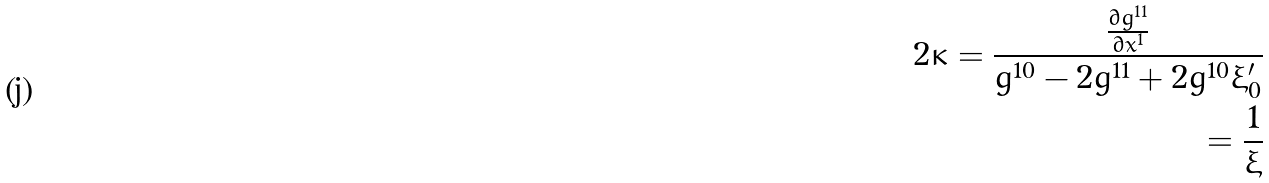<formula> <loc_0><loc_0><loc_500><loc_500>2 \kappa = \frac { \frac { \partial g ^ { 1 1 } } { \partial x ^ { 1 } } } { g ^ { 1 0 } - 2 g ^ { 1 1 } + 2 g ^ { 1 0 } \xi ^ { \prime } _ { 0 } } \\ = \frac { 1 } { \xi }</formula> 